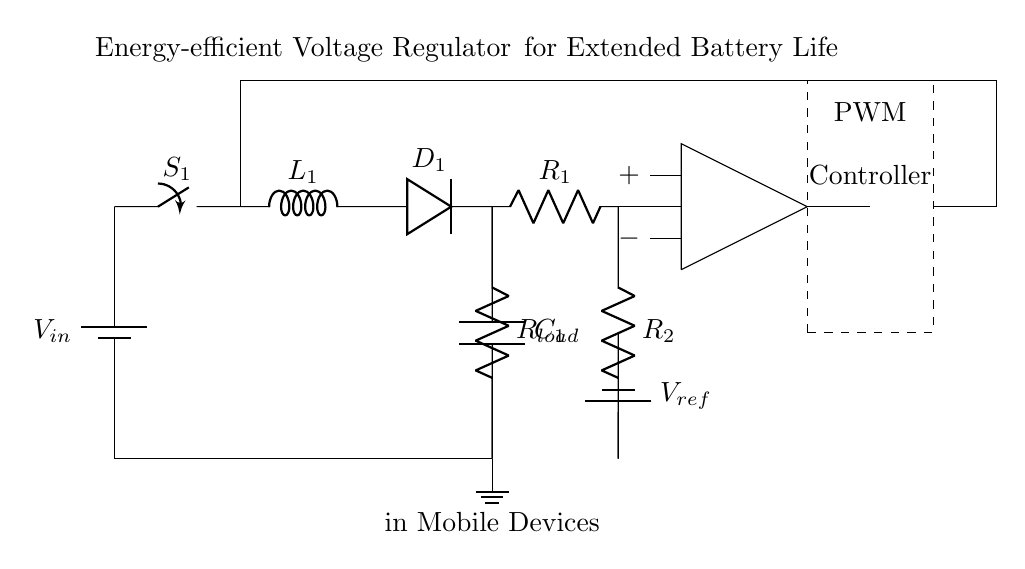What is the input voltage of this circuit? The input voltage is denoted as V_in in the circuit diagram, which is represented at the top left section.
Answer: V_in What type of switch is used in the circuit? The circuit includes a symbol labeled as S_1, which is a standard representation of a switch in circuit diagrams.
Answer: Switch How many capacitors are present in this circuit? Looking at the circuit diagram, there is only one capacitor symbol labeled as C_1 located in the upper right section, connected to the load resistor.
Answer: One What are R_1 and R_2 used for in this circuit? Resistors R_1 and R_2 are arranged in a feedback network for the op-amp, allowing voltage division, which is essential for regulating output voltage based on the reference voltage.
Answer: Feedback What is the function of the PWM controller in this circuit? The PWM (Pulse Width Modulation) controller regulates the switching of the voltage regulator, controlling the duty cycle to adjust output voltage and thereby extending battery life.
Answer: Regulation What does V_ref represent in this circuit? V_ref is a reference voltage that sets a threshold for the operation of the op-amp, influencing the feedback mechanism to stabilize the output voltage.
Answer: Reference voltage What is the purpose of the inductor L_1 in this circuit? The inductor L_1 is part of the energy storage element in the voltage regulator, allowing the circuit to smooth out current flow and improve efficiency by storing and releasing energy.
Answer: Energy storage 